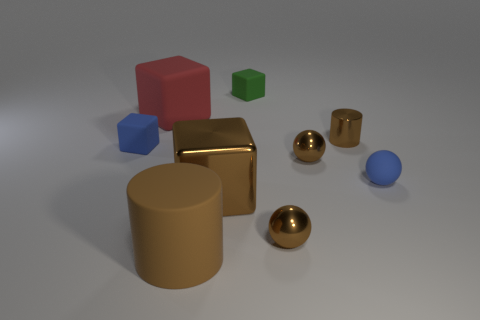Subtract all blue cubes. How many cubes are left? 3 Subtract all blue spheres. How many spheres are left? 2 Subtract all balls. How many objects are left? 6 Subtract all yellow blocks. How many red cylinders are left? 0 Add 3 metallic cylinders. How many metallic cylinders exist? 4 Subtract 0 purple cylinders. How many objects are left? 9 Subtract 1 cylinders. How many cylinders are left? 1 Subtract all cyan cylinders. Subtract all purple balls. How many cylinders are left? 2 Subtract all big red rubber objects. Subtract all small matte things. How many objects are left? 5 Add 8 metallic balls. How many metallic balls are left? 10 